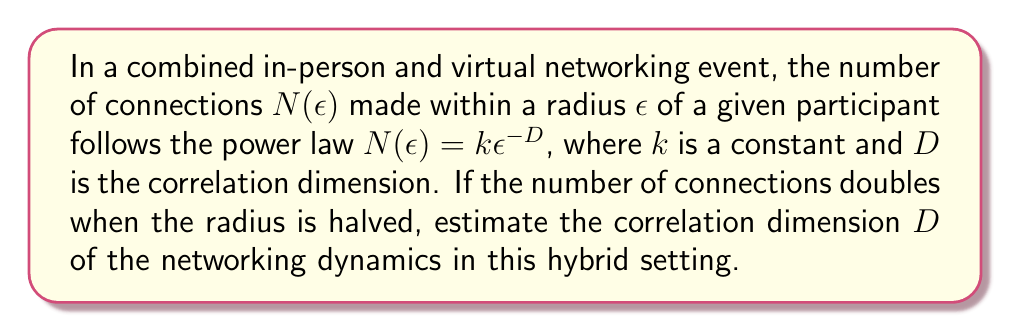Help me with this question. Let's approach this step-by-step:

1) We're given that $N(\epsilon) = k\epsilon^{-D}$, where $D$ is the correlation dimension we need to find.

2) We're told that when the radius is halved, the number of connections doubles. Let's express this mathematically:

   $N(\frac{\epsilon}{2}) = 2N(\epsilon)$

3) Let's substitute the power law equation into both sides:

   $k(\frac{\epsilon}{2})^{-D} = 2k\epsilon^{-D}$

4) The $k$ cancels out on both sides:

   $(\frac{\epsilon}{2})^{-D} = 2\epsilon^{-D}$

5) Let's simplify the left side:

   $(\frac{1}{2})^D \epsilon^{-D} = 2\epsilon^{-D}$

6) The $\epsilon^{-D}$ cancels out on both sides:

   $(\frac{1}{2})^D = 2$

7) Now, let's take the logarithm of both sides:

   $D \log(\frac{1}{2}) = \log(2)$

8) Simplify:

   $-D \log(2) = \log(2)$

9) Solve for $D$:

   $D = -\frac{\log(2)}{\log(2)} = -(-1) = 1$

Therefore, the correlation dimension $D$ is estimated to be 1.
Answer: $D = 1$ 